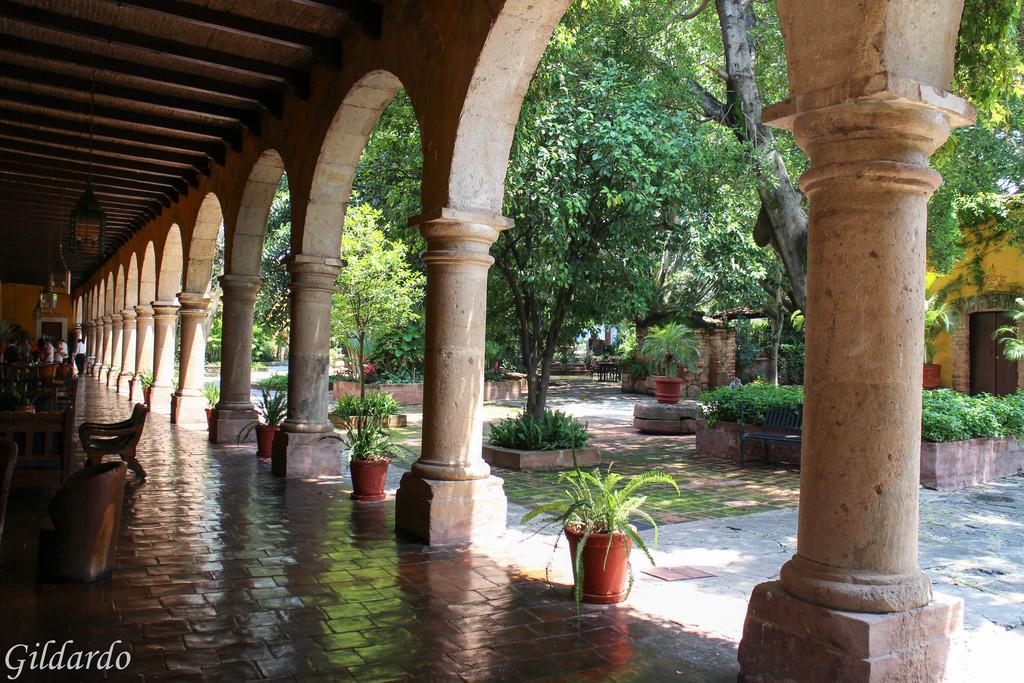Could you give a brief overview of what you see in this image? Here, we can see a floor and there are some chairs on the floor, there are some columns, at the right side there are some green color trees. 